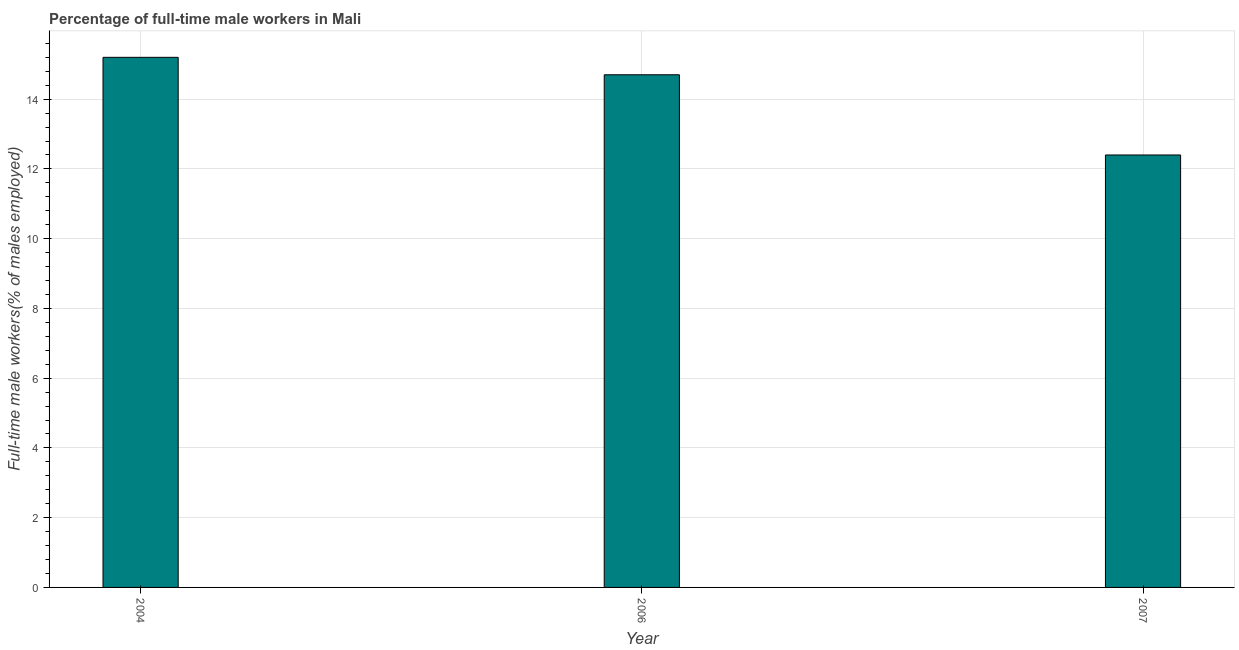Does the graph contain any zero values?
Provide a succinct answer. No. What is the title of the graph?
Provide a short and direct response. Percentage of full-time male workers in Mali. What is the label or title of the X-axis?
Ensure brevity in your answer.  Year. What is the label or title of the Y-axis?
Give a very brief answer. Full-time male workers(% of males employed). What is the percentage of full-time male workers in 2007?
Keep it short and to the point. 12.4. Across all years, what is the maximum percentage of full-time male workers?
Offer a very short reply. 15.2. Across all years, what is the minimum percentage of full-time male workers?
Your response must be concise. 12.4. In which year was the percentage of full-time male workers minimum?
Ensure brevity in your answer.  2007. What is the sum of the percentage of full-time male workers?
Offer a terse response. 42.3. What is the difference between the percentage of full-time male workers in 2006 and 2007?
Ensure brevity in your answer.  2.3. What is the average percentage of full-time male workers per year?
Your answer should be very brief. 14.1. What is the median percentage of full-time male workers?
Keep it short and to the point. 14.7. In how many years, is the percentage of full-time male workers greater than 10.8 %?
Make the answer very short. 3. Do a majority of the years between 2007 and 2004 (inclusive) have percentage of full-time male workers greater than 11.6 %?
Provide a succinct answer. Yes. What is the ratio of the percentage of full-time male workers in 2004 to that in 2006?
Give a very brief answer. 1.03. Is the percentage of full-time male workers in 2006 less than that in 2007?
Provide a succinct answer. No. Is the difference between the percentage of full-time male workers in 2004 and 2006 greater than the difference between any two years?
Your response must be concise. No. What is the difference between the highest and the second highest percentage of full-time male workers?
Ensure brevity in your answer.  0.5. In how many years, is the percentage of full-time male workers greater than the average percentage of full-time male workers taken over all years?
Give a very brief answer. 2. How many bars are there?
Keep it short and to the point. 3. How many years are there in the graph?
Ensure brevity in your answer.  3. What is the difference between two consecutive major ticks on the Y-axis?
Offer a terse response. 2. Are the values on the major ticks of Y-axis written in scientific E-notation?
Your answer should be compact. No. What is the Full-time male workers(% of males employed) in 2004?
Offer a very short reply. 15.2. What is the Full-time male workers(% of males employed) in 2006?
Your answer should be compact. 14.7. What is the Full-time male workers(% of males employed) of 2007?
Ensure brevity in your answer.  12.4. What is the difference between the Full-time male workers(% of males employed) in 2004 and 2006?
Provide a succinct answer. 0.5. What is the difference between the Full-time male workers(% of males employed) in 2004 and 2007?
Make the answer very short. 2.8. What is the ratio of the Full-time male workers(% of males employed) in 2004 to that in 2006?
Your answer should be very brief. 1.03. What is the ratio of the Full-time male workers(% of males employed) in 2004 to that in 2007?
Your answer should be very brief. 1.23. What is the ratio of the Full-time male workers(% of males employed) in 2006 to that in 2007?
Provide a succinct answer. 1.19. 